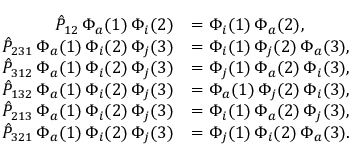Convert formula to latex. <formula><loc_0><loc_0><loc_500><loc_500>\begin{array} { r l } { \hat { P } _ { 1 2 } \, \Phi _ { a } ( 1 ) \, \Phi _ { i } ( 2 ) } & { = \Phi _ { i } ( 1 ) \, \Phi _ { a } ( 2 ) , } \\ { \hat { P } _ { 2 3 1 } \, \Phi _ { a } ( 1 ) \, \Phi _ { i } ( 2 ) \, \Phi _ { j } ( 3 ) } & { = \Phi _ { i } ( 1 ) \, \Phi _ { j } ( 2 ) \, \Phi _ { a } ( 3 ) , } \\ { \hat { P } _ { 3 1 2 } \, \Phi _ { a } ( 1 ) \, \Phi _ { i } ( 2 ) \, \Phi _ { j } ( 3 ) } & { = \Phi _ { j } ( 1 ) \, \Phi _ { a } ( 2 ) \, \Phi _ { i } ( 3 ) , } \\ { \hat { P } _ { 1 3 2 } \, \Phi _ { a } ( 1 ) \, \Phi _ { i } ( 2 ) \, \Phi _ { j } ( 3 ) } & { = \Phi _ { a } ( 1 ) \, \Phi _ { j } ( 2 ) \, \Phi _ { i } ( 3 ) , } \\ { \hat { P } _ { 2 1 3 } \, \Phi _ { a } ( 1 ) \, \Phi _ { i } ( 2 ) \, \Phi _ { j } ( 3 ) } & { = \Phi _ { i } ( 1 ) \, \Phi _ { a } ( 2 ) \, \Phi _ { j } ( 3 ) , } \\ { \hat { P } _ { 3 2 1 } \, \Phi _ { a } ( 1 ) \, \Phi _ { i } ( 2 ) \, \Phi _ { j } ( 3 ) } & { = \Phi _ { j } ( 1 ) \, \Phi _ { i } ( 2 ) \, \Phi _ { a } ( 3 ) . } \end{array}</formula> 